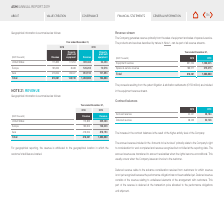According to Asm International Nv's financial document, Where can the products and services described by nature be found? According to the financial document, Note 1. The relevant text states: "The products and services described by nature in Note 1, can be part of all revenue streams...." Also, What is the  Equipment revenue in 2018? According to the financial document, 631,504 (in thousands). The relevant text states: "Equipment revenue 631,504 1,068,645..." Also, What is the  Spares & service revenue for 2019? According to the financial document, 215,215 (in thousands). The relevant text states: "Spares & service revenue 186,577 215,215..." Also, can you calculate: What is the patent litigation & arbitration settlements expressed as a percentage of Equipment revenue in 2019? Based on the calculation: 159 millions / 1,068,645 thousands, the result is 14.88 (percentage). This is based on the information: "Equipment revenue 631,504 1,068,645 the patent litigation & arbitration settlements (€159 million) are included..." The key data points involved are: 1,068,645, 159. Also, can you calculate: What is the change in total revenue from 2018 to 2019? Based on the calculation:  1,283,860 - 818,081 , the result is 465779 (in thousands). This is based on the information: "Total 818,081 148,749 1,283,860 164,863 Total 818,081 148,749 1,283,860 164,863..." The key data points involved are: 1,283,860, 818,081. Additionally, What was the component that comprised of the largest proportion of revenue for 2018 and 2019 respectively? The document shows two values: Equipment revenue and Equipment revenue. From the document: "Equipment revenue 631,504 1,068,645..." 